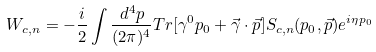<formula> <loc_0><loc_0><loc_500><loc_500>W _ { c , n } = - \frac { i } { 2 } \int \frac { d ^ { 4 } p } { ( 2 \pi ) ^ { 4 } } T r [ \gamma ^ { 0 } p _ { 0 } + \vec { \gamma } \cdot \vec { p } ] S _ { c , n } ( p _ { 0 } , \vec { p } ) e ^ { i \eta p _ { 0 } }</formula> 